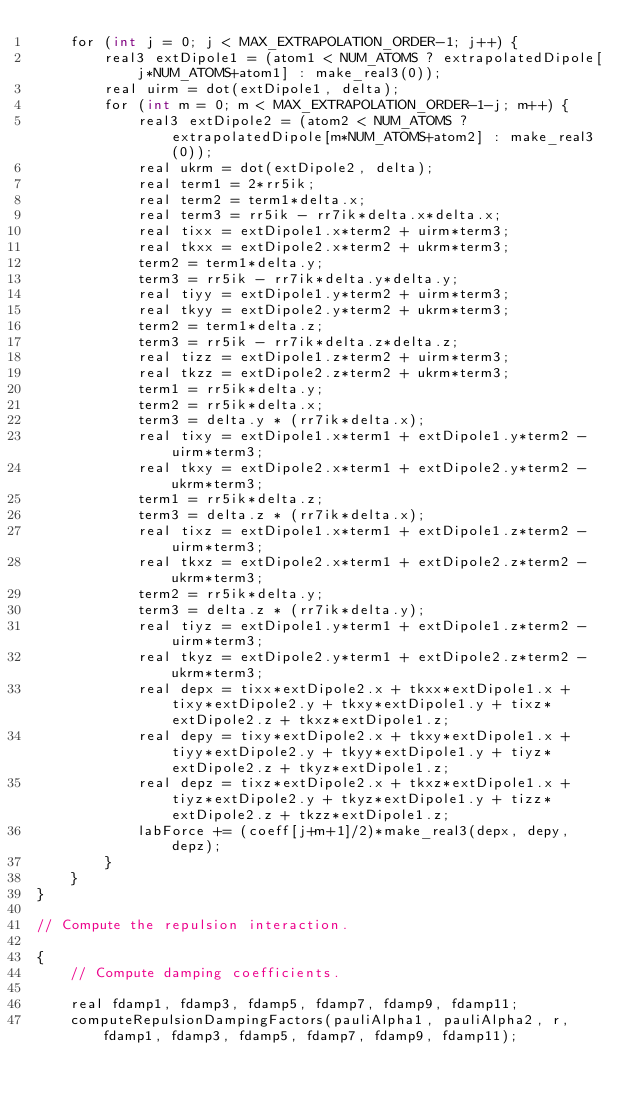Convert code to text. <code><loc_0><loc_0><loc_500><loc_500><_Cuda_>    for (int j = 0; j < MAX_EXTRAPOLATION_ORDER-1; j++) {
        real3 extDipole1 = (atom1 < NUM_ATOMS ? extrapolatedDipole[j*NUM_ATOMS+atom1] : make_real3(0));
        real uirm = dot(extDipole1, delta);
        for (int m = 0; m < MAX_EXTRAPOLATION_ORDER-1-j; m++) {
            real3 extDipole2 = (atom2 < NUM_ATOMS ? extrapolatedDipole[m*NUM_ATOMS+atom2] : make_real3(0));
            real ukrm = dot(extDipole2, delta);
            real term1 = 2*rr5ik;
            real term2 = term1*delta.x;
            real term3 = rr5ik - rr7ik*delta.x*delta.x;
            real tixx = extDipole1.x*term2 + uirm*term3;
            real tkxx = extDipole2.x*term2 + ukrm*term3;
            term2 = term1*delta.y;
            term3 = rr5ik - rr7ik*delta.y*delta.y;
            real tiyy = extDipole1.y*term2 + uirm*term3;
            real tkyy = extDipole2.y*term2 + ukrm*term3;
            term2 = term1*delta.z;
            term3 = rr5ik - rr7ik*delta.z*delta.z;
            real tizz = extDipole1.z*term2 + uirm*term3;
            real tkzz = extDipole2.z*term2 + ukrm*term3;
            term1 = rr5ik*delta.y;
            term2 = rr5ik*delta.x;
            term3 = delta.y * (rr7ik*delta.x);
            real tixy = extDipole1.x*term1 + extDipole1.y*term2 - uirm*term3;
            real tkxy = extDipole2.x*term1 + extDipole2.y*term2 - ukrm*term3;
            term1 = rr5ik*delta.z;
            term3 = delta.z * (rr7ik*delta.x);
            real tixz = extDipole1.x*term1 + extDipole1.z*term2 - uirm*term3;
            real tkxz = extDipole2.x*term1 + extDipole2.z*term2 - ukrm*term3;
            term2 = rr5ik*delta.y;
            term3 = delta.z * (rr7ik*delta.y);
            real tiyz = extDipole1.y*term1 + extDipole1.z*term2 - uirm*term3;
            real tkyz = extDipole2.y*term1 + extDipole2.z*term2 - ukrm*term3;
            real depx = tixx*extDipole2.x + tkxx*extDipole1.x + tixy*extDipole2.y + tkxy*extDipole1.y + tixz*extDipole2.z + tkxz*extDipole1.z;
            real depy = tixy*extDipole2.x + tkxy*extDipole1.x + tiyy*extDipole2.y + tkyy*extDipole1.y + tiyz*extDipole2.z + tkyz*extDipole1.z;
            real depz = tixz*extDipole2.x + tkxz*extDipole1.x + tiyz*extDipole2.y + tkyz*extDipole1.y + tizz*extDipole2.z + tkzz*extDipole1.z;
            labForce += (coeff[j+m+1]/2)*make_real3(depx, depy, depz);
        }
    }
}

// Compute the repulsion interaction.

{
    // Compute damping coefficients.

    real fdamp1, fdamp3, fdamp5, fdamp7, fdamp9, fdamp11;
    computeRepulsionDampingFactors(pauliAlpha1, pauliAlpha2, r, fdamp1, fdamp3, fdamp5, fdamp7, fdamp9, fdamp11);
</code> 